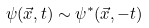<formula> <loc_0><loc_0><loc_500><loc_500>\psi ( \vec { x } , t ) \sim \psi ^ { \ast } ( \vec { x } , - t )</formula> 